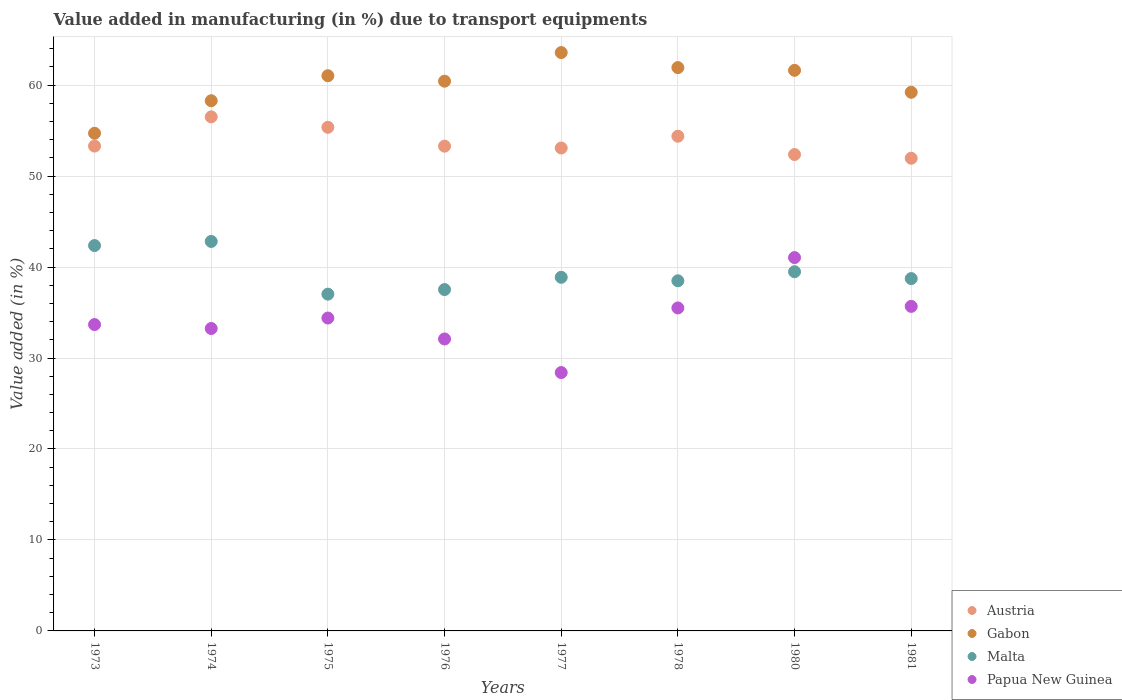How many different coloured dotlines are there?
Provide a short and direct response. 4. Is the number of dotlines equal to the number of legend labels?
Provide a short and direct response. Yes. What is the percentage of value added in manufacturing due to transport equipments in Austria in 1977?
Provide a succinct answer. 53.09. Across all years, what is the maximum percentage of value added in manufacturing due to transport equipments in Gabon?
Ensure brevity in your answer.  63.58. Across all years, what is the minimum percentage of value added in manufacturing due to transport equipments in Papua New Guinea?
Give a very brief answer. 28.4. In which year was the percentage of value added in manufacturing due to transport equipments in Papua New Guinea minimum?
Provide a succinct answer. 1977. What is the total percentage of value added in manufacturing due to transport equipments in Papua New Guinea in the graph?
Offer a terse response. 274.05. What is the difference between the percentage of value added in manufacturing due to transport equipments in Austria in 1973 and that in 1980?
Offer a very short reply. 0.93. What is the difference between the percentage of value added in manufacturing due to transport equipments in Malta in 1980 and the percentage of value added in manufacturing due to transport equipments in Papua New Guinea in 1976?
Provide a short and direct response. 7.39. What is the average percentage of value added in manufacturing due to transport equipments in Malta per year?
Keep it short and to the point. 39.41. In the year 1978, what is the difference between the percentage of value added in manufacturing due to transport equipments in Malta and percentage of value added in manufacturing due to transport equipments in Gabon?
Your answer should be compact. -23.44. In how many years, is the percentage of value added in manufacturing due to transport equipments in Gabon greater than 54 %?
Ensure brevity in your answer.  8. What is the ratio of the percentage of value added in manufacturing due to transport equipments in Austria in 1976 to that in 1978?
Offer a terse response. 0.98. Is the difference between the percentage of value added in manufacturing due to transport equipments in Malta in 1980 and 1981 greater than the difference between the percentage of value added in manufacturing due to transport equipments in Gabon in 1980 and 1981?
Your response must be concise. No. What is the difference between the highest and the second highest percentage of value added in manufacturing due to transport equipments in Papua New Guinea?
Ensure brevity in your answer.  5.36. What is the difference between the highest and the lowest percentage of value added in manufacturing due to transport equipments in Malta?
Give a very brief answer. 5.8. Is the sum of the percentage of value added in manufacturing due to transport equipments in Gabon in 1973 and 1976 greater than the maximum percentage of value added in manufacturing due to transport equipments in Malta across all years?
Provide a short and direct response. Yes. Is it the case that in every year, the sum of the percentage of value added in manufacturing due to transport equipments in Malta and percentage of value added in manufacturing due to transport equipments in Austria  is greater than the sum of percentage of value added in manufacturing due to transport equipments in Gabon and percentage of value added in manufacturing due to transport equipments in Papua New Guinea?
Offer a terse response. No. Is the percentage of value added in manufacturing due to transport equipments in Gabon strictly greater than the percentage of value added in manufacturing due to transport equipments in Papua New Guinea over the years?
Offer a very short reply. Yes. Is the percentage of value added in manufacturing due to transport equipments in Austria strictly less than the percentage of value added in manufacturing due to transport equipments in Gabon over the years?
Your response must be concise. Yes. How many years are there in the graph?
Offer a terse response. 8. Does the graph contain any zero values?
Your response must be concise. No. Does the graph contain grids?
Keep it short and to the point. Yes. Where does the legend appear in the graph?
Offer a very short reply. Bottom right. How many legend labels are there?
Make the answer very short. 4. How are the legend labels stacked?
Ensure brevity in your answer.  Vertical. What is the title of the graph?
Offer a very short reply. Value added in manufacturing (in %) due to transport equipments. What is the label or title of the X-axis?
Your response must be concise. Years. What is the label or title of the Y-axis?
Provide a short and direct response. Value added (in %). What is the Value added (in %) in Austria in 1973?
Provide a succinct answer. 53.3. What is the Value added (in %) in Gabon in 1973?
Give a very brief answer. 54.71. What is the Value added (in %) in Malta in 1973?
Ensure brevity in your answer.  42.36. What is the Value added (in %) in Papua New Guinea in 1973?
Give a very brief answer. 33.68. What is the Value added (in %) in Austria in 1974?
Your response must be concise. 56.51. What is the Value added (in %) of Gabon in 1974?
Provide a short and direct response. 58.29. What is the Value added (in %) in Malta in 1974?
Provide a succinct answer. 42.82. What is the Value added (in %) in Papua New Guinea in 1974?
Your response must be concise. 33.25. What is the Value added (in %) of Austria in 1975?
Give a very brief answer. 55.36. What is the Value added (in %) of Gabon in 1975?
Keep it short and to the point. 61.03. What is the Value added (in %) in Malta in 1975?
Ensure brevity in your answer.  37.02. What is the Value added (in %) in Papua New Guinea in 1975?
Ensure brevity in your answer.  34.4. What is the Value added (in %) in Austria in 1976?
Keep it short and to the point. 53.29. What is the Value added (in %) in Gabon in 1976?
Your answer should be very brief. 60.43. What is the Value added (in %) in Malta in 1976?
Your response must be concise. 37.53. What is the Value added (in %) in Papua New Guinea in 1976?
Give a very brief answer. 32.1. What is the Value added (in %) of Austria in 1977?
Provide a succinct answer. 53.09. What is the Value added (in %) of Gabon in 1977?
Your answer should be very brief. 63.58. What is the Value added (in %) in Malta in 1977?
Give a very brief answer. 38.88. What is the Value added (in %) of Papua New Guinea in 1977?
Offer a very short reply. 28.4. What is the Value added (in %) of Austria in 1978?
Keep it short and to the point. 54.38. What is the Value added (in %) in Gabon in 1978?
Make the answer very short. 61.93. What is the Value added (in %) in Malta in 1978?
Provide a short and direct response. 38.49. What is the Value added (in %) in Papua New Guinea in 1978?
Ensure brevity in your answer.  35.51. What is the Value added (in %) in Austria in 1980?
Provide a short and direct response. 52.37. What is the Value added (in %) in Gabon in 1980?
Ensure brevity in your answer.  61.63. What is the Value added (in %) of Malta in 1980?
Ensure brevity in your answer.  39.49. What is the Value added (in %) of Papua New Guinea in 1980?
Your answer should be compact. 41.04. What is the Value added (in %) in Austria in 1981?
Your answer should be compact. 51.96. What is the Value added (in %) of Gabon in 1981?
Give a very brief answer. 59.22. What is the Value added (in %) in Malta in 1981?
Ensure brevity in your answer.  38.73. What is the Value added (in %) in Papua New Guinea in 1981?
Keep it short and to the point. 35.68. Across all years, what is the maximum Value added (in %) of Austria?
Offer a very short reply. 56.51. Across all years, what is the maximum Value added (in %) of Gabon?
Give a very brief answer. 63.58. Across all years, what is the maximum Value added (in %) of Malta?
Your answer should be very brief. 42.82. Across all years, what is the maximum Value added (in %) in Papua New Guinea?
Your answer should be very brief. 41.04. Across all years, what is the minimum Value added (in %) of Austria?
Your response must be concise. 51.96. Across all years, what is the minimum Value added (in %) of Gabon?
Your answer should be very brief. 54.71. Across all years, what is the minimum Value added (in %) in Malta?
Keep it short and to the point. 37.02. Across all years, what is the minimum Value added (in %) of Papua New Guinea?
Offer a terse response. 28.4. What is the total Value added (in %) in Austria in the graph?
Give a very brief answer. 430.28. What is the total Value added (in %) of Gabon in the graph?
Give a very brief answer. 480.81. What is the total Value added (in %) of Malta in the graph?
Offer a very short reply. 315.32. What is the total Value added (in %) in Papua New Guinea in the graph?
Your response must be concise. 274.05. What is the difference between the Value added (in %) in Austria in 1973 and that in 1974?
Keep it short and to the point. -3.21. What is the difference between the Value added (in %) in Gabon in 1973 and that in 1974?
Your answer should be very brief. -3.58. What is the difference between the Value added (in %) of Malta in 1973 and that in 1974?
Keep it short and to the point. -0.45. What is the difference between the Value added (in %) in Papua New Guinea in 1973 and that in 1974?
Make the answer very short. 0.43. What is the difference between the Value added (in %) in Austria in 1973 and that in 1975?
Your answer should be compact. -2.06. What is the difference between the Value added (in %) of Gabon in 1973 and that in 1975?
Keep it short and to the point. -6.32. What is the difference between the Value added (in %) in Malta in 1973 and that in 1975?
Provide a succinct answer. 5.34. What is the difference between the Value added (in %) in Papua New Guinea in 1973 and that in 1975?
Offer a terse response. -0.72. What is the difference between the Value added (in %) in Austria in 1973 and that in 1976?
Make the answer very short. 0.01. What is the difference between the Value added (in %) of Gabon in 1973 and that in 1976?
Your response must be concise. -5.72. What is the difference between the Value added (in %) in Malta in 1973 and that in 1976?
Your answer should be compact. 4.84. What is the difference between the Value added (in %) of Papua New Guinea in 1973 and that in 1976?
Offer a terse response. 1.58. What is the difference between the Value added (in %) of Austria in 1973 and that in 1977?
Offer a terse response. 0.21. What is the difference between the Value added (in %) in Gabon in 1973 and that in 1977?
Your answer should be compact. -8.87. What is the difference between the Value added (in %) in Malta in 1973 and that in 1977?
Provide a succinct answer. 3.49. What is the difference between the Value added (in %) in Papua New Guinea in 1973 and that in 1977?
Provide a succinct answer. 5.28. What is the difference between the Value added (in %) of Austria in 1973 and that in 1978?
Provide a short and direct response. -1.08. What is the difference between the Value added (in %) of Gabon in 1973 and that in 1978?
Keep it short and to the point. -7.22. What is the difference between the Value added (in %) of Malta in 1973 and that in 1978?
Provide a succinct answer. 3.87. What is the difference between the Value added (in %) in Papua New Guinea in 1973 and that in 1978?
Give a very brief answer. -1.83. What is the difference between the Value added (in %) of Austria in 1973 and that in 1980?
Your answer should be compact. 0.93. What is the difference between the Value added (in %) in Gabon in 1973 and that in 1980?
Provide a succinct answer. -6.92. What is the difference between the Value added (in %) in Malta in 1973 and that in 1980?
Ensure brevity in your answer.  2.88. What is the difference between the Value added (in %) in Papua New Guinea in 1973 and that in 1980?
Provide a succinct answer. -7.36. What is the difference between the Value added (in %) in Austria in 1973 and that in 1981?
Your response must be concise. 1.34. What is the difference between the Value added (in %) of Gabon in 1973 and that in 1981?
Your response must be concise. -4.51. What is the difference between the Value added (in %) in Malta in 1973 and that in 1981?
Provide a short and direct response. 3.63. What is the difference between the Value added (in %) in Papua New Guinea in 1973 and that in 1981?
Your answer should be compact. -2. What is the difference between the Value added (in %) in Austria in 1974 and that in 1975?
Provide a short and direct response. 1.15. What is the difference between the Value added (in %) of Gabon in 1974 and that in 1975?
Ensure brevity in your answer.  -2.75. What is the difference between the Value added (in %) in Malta in 1974 and that in 1975?
Ensure brevity in your answer.  5.8. What is the difference between the Value added (in %) of Papua New Guinea in 1974 and that in 1975?
Your answer should be compact. -1.15. What is the difference between the Value added (in %) of Austria in 1974 and that in 1976?
Keep it short and to the point. 3.22. What is the difference between the Value added (in %) of Gabon in 1974 and that in 1976?
Provide a short and direct response. -2.15. What is the difference between the Value added (in %) in Malta in 1974 and that in 1976?
Provide a succinct answer. 5.29. What is the difference between the Value added (in %) of Papua New Guinea in 1974 and that in 1976?
Provide a succinct answer. 1.15. What is the difference between the Value added (in %) of Austria in 1974 and that in 1977?
Your response must be concise. 3.42. What is the difference between the Value added (in %) in Gabon in 1974 and that in 1977?
Offer a terse response. -5.29. What is the difference between the Value added (in %) of Malta in 1974 and that in 1977?
Your answer should be very brief. 3.94. What is the difference between the Value added (in %) of Papua New Guinea in 1974 and that in 1977?
Ensure brevity in your answer.  4.84. What is the difference between the Value added (in %) in Austria in 1974 and that in 1978?
Provide a short and direct response. 2.13. What is the difference between the Value added (in %) of Gabon in 1974 and that in 1978?
Your response must be concise. -3.64. What is the difference between the Value added (in %) in Malta in 1974 and that in 1978?
Provide a short and direct response. 4.32. What is the difference between the Value added (in %) of Papua New Guinea in 1974 and that in 1978?
Provide a short and direct response. -2.26. What is the difference between the Value added (in %) in Austria in 1974 and that in 1980?
Your response must be concise. 4.14. What is the difference between the Value added (in %) in Gabon in 1974 and that in 1980?
Make the answer very short. -3.34. What is the difference between the Value added (in %) of Malta in 1974 and that in 1980?
Your answer should be very brief. 3.33. What is the difference between the Value added (in %) of Papua New Guinea in 1974 and that in 1980?
Offer a very short reply. -7.8. What is the difference between the Value added (in %) of Austria in 1974 and that in 1981?
Ensure brevity in your answer.  4.55. What is the difference between the Value added (in %) in Gabon in 1974 and that in 1981?
Give a very brief answer. -0.93. What is the difference between the Value added (in %) in Malta in 1974 and that in 1981?
Offer a terse response. 4.08. What is the difference between the Value added (in %) of Papua New Guinea in 1974 and that in 1981?
Offer a terse response. -2.43. What is the difference between the Value added (in %) of Austria in 1975 and that in 1976?
Your answer should be compact. 2.07. What is the difference between the Value added (in %) in Gabon in 1975 and that in 1976?
Offer a terse response. 0.6. What is the difference between the Value added (in %) in Malta in 1975 and that in 1976?
Your response must be concise. -0.5. What is the difference between the Value added (in %) of Papua New Guinea in 1975 and that in 1976?
Provide a short and direct response. 2.3. What is the difference between the Value added (in %) of Austria in 1975 and that in 1977?
Your answer should be very brief. 2.27. What is the difference between the Value added (in %) of Gabon in 1975 and that in 1977?
Offer a terse response. -2.55. What is the difference between the Value added (in %) in Malta in 1975 and that in 1977?
Offer a terse response. -1.85. What is the difference between the Value added (in %) of Papua New Guinea in 1975 and that in 1977?
Offer a terse response. 5.99. What is the difference between the Value added (in %) in Austria in 1975 and that in 1978?
Your answer should be compact. 0.98. What is the difference between the Value added (in %) of Gabon in 1975 and that in 1978?
Offer a terse response. -0.89. What is the difference between the Value added (in %) in Malta in 1975 and that in 1978?
Your answer should be compact. -1.47. What is the difference between the Value added (in %) in Papua New Guinea in 1975 and that in 1978?
Make the answer very short. -1.11. What is the difference between the Value added (in %) in Austria in 1975 and that in 1980?
Offer a terse response. 2.99. What is the difference between the Value added (in %) in Gabon in 1975 and that in 1980?
Give a very brief answer. -0.59. What is the difference between the Value added (in %) in Malta in 1975 and that in 1980?
Offer a very short reply. -2.47. What is the difference between the Value added (in %) of Papua New Guinea in 1975 and that in 1980?
Your answer should be compact. -6.65. What is the difference between the Value added (in %) of Austria in 1975 and that in 1981?
Offer a very short reply. 3.4. What is the difference between the Value added (in %) in Gabon in 1975 and that in 1981?
Make the answer very short. 1.82. What is the difference between the Value added (in %) of Malta in 1975 and that in 1981?
Keep it short and to the point. -1.71. What is the difference between the Value added (in %) of Papua New Guinea in 1975 and that in 1981?
Your answer should be very brief. -1.28. What is the difference between the Value added (in %) of Austria in 1976 and that in 1977?
Give a very brief answer. 0.2. What is the difference between the Value added (in %) in Gabon in 1976 and that in 1977?
Give a very brief answer. -3.15. What is the difference between the Value added (in %) of Malta in 1976 and that in 1977?
Offer a very short reply. -1.35. What is the difference between the Value added (in %) in Papua New Guinea in 1976 and that in 1977?
Keep it short and to the point. 3.69. What is the difference between the Value added (in %) in Austria in 1976 and that in 1978?
Provide a succinct answer. -1.09. What is the difference between the Value added (in %) in Gabon in 1976 and that in 1978?
Your answer should be compact. -1.49. What is the difference between the Value added (in %) of Malta in 1976 and that in 1978?
Offer a terse response. -0.97. What is the difference between the Value added (in %) of Papua New Guinea in 1976 and that in 1978?
Make the answer very short. -3.41. What is the difference between the Value added (in %) of Austria in 1976 and that in 1980?
Offer a terse response. 0.92. What is the difference between the Value added (in %) of Gabon in 1976 and that in 1980?
Keep it short and to the point. -1.19. What is the difference between the Value added (in %) of Malta in 1976 and that in 1980?
Offer a terse response. -1.96. What is the difference between the Value added (in %) of Papua New Guinea in 1976 and that in 1980?
Provide a succinct answer. -8.95. What is the difference between the Value added (in %) in Austria in 1976 and that in 1981?
Keep it short and to the point. 1.33. What is the difference between the Value added (in %) in Gabon in 1976 and that in 1981?
Offer a very short reply. 1.22. What is the difference between the Value added (in %) of Malta in 1976 and that in 1981?
Provide a succinct answer. -1.21. What is the difference between the Value added (in %) in Papua New Guinea in 1976 and that in 1981?
Your response must be concise. -3.58. What is the difference between the Value added (in %) of Austria in 1977 and that in 1978?
Offer a very short reply. -1.29. What is the difference between the Value added (in %) in Gabon in 1977 and that in 1978?
Give a very brief answer. 1.65. What is the difference between the Value added (in %) of Malta in 1977 and that in 1978?
Your response must be concise. 0.38. What is the difference between the Value added (in %) in Papua New Guinea in 1977 and that in 1978?
Your answer should be very brief. -7.1. What is the difference between the Value added (in %) of Austria in 1977 and that in 1980?
Your answer should be compact. 0.72. What is the difference between the Value added (in %) of Gabon in 1977 and that in 1980?
Make the answer very short. 1.95. What is the difference between the Value added (in %) in Malta in 1977 and that in 1980?
Ensure brevity in your answer.  -0.61. What is the difference between the Value added (in %) of Papua New Guinea in 1977 and that in 1980?
Provide a succinct answer. -12.64. What is the difference between the Value added (in %) in Austria in 1977 and that in 1981?
Give a very brief answer. 1.13. What is the difference between the Value added (in %) in Gabon in 1977 and that in 1981?
Your answer should be very brief. 4.36. What is the difference between the Value added (in %) in Malta in 1977 and that in 1981?
Your response must be concise. 0.14. What is the difference between the Value added (in %) in Papua New Guinea in 1977 and that in 1981?
Your response must be concise. -7.28. What is the difference between the Value added (in %) in Austria in 1978 and that in 1980?
Offer a very short reply. 2.01. What is the difference between the Value added (in %) of Gabon in 1978 and that in 1980?
Your answer should be compact. 0.3. What is the difference between the Value added (in %) in Malta in 1978 and that in 1980?
Offer a terse response. -0.99. What is the difference between the Value added (in %) of Papua New Guinea in 1978 and that in 1980?
Offer a terse response. -5.54. What is the difference between the Value added (in %) of Austria in 1978 and that in 1981?
Offer a terse response. 2.42. What is the difference between the Value added (in %) in Gabon in 1978 and that in 1981?
Provide a short and direct response. 2.71. What is the difference between the Value added (in %) in Malta in 1978 and that in 1981?
Ensure brevity in your answer.  -0.24. What is the difference between the Value added (in %) in Papua New Guinea in 1978 and that in 1981?
Your answer should be compact. -0.17. What is the difference between the Value added (in %) in Austria in 1980 and that in 1981?
Your answer should be compact. 0.41. What is the difference between the Value added (in %) of Gabon in 1980 and that in 1981?
Provide a succinct answer. 2.41. What is the difference between the Value added (in %) of Malta in 1980 and that in 1981?
Provide a succinct answer. 0.75. What is the difference between the Value added (in %) of Papua New Guinea in 1980 and that in 1981?
Provide a short and direct response. 5.36. What is the difference between the Value added (in %) in Austria in 1973 and the Value added (in %) in Gabon in 1974?
Ensure brevity in your answer.  -4.98. What is the difference between the Value added (in %) of Austria in 1973 and the Value added (in %) of Malta in 1974?
Your answer should be very brief. 10.48. What is the difference between the Value added (in %) in Austria in 1973 and the Value added (in %) in Papua New Guinea in 1974?
Your answer should be very brief. 20.06. What is the difference between the Value added (in %) in Gabon in 1973 and the Value added (in %) in Malta in 1974?
Your answer should be very brief. 11.89. What is the difference between the Value added (in %) of Gabon in 1973 and the Value added (in %) of Papua New Guinea in 1974?
Your answer should be very brief. 21.46. What is the difference between the Value added (in %) of Malta in 1973 and the Value added (in %) of Papua New Guinea in 1974?
Your response must be concise. 9.12. What is the difference between the Value added (in %) of Austria in 1973 and the Value added (in %) of Gabon in 1975?
Your answer should be compact. -7.73. What is the difference between the Value added (in %) in Austria in 1973 and the Value added (in %) in Malta in 1975?
Your response must be concise. 16.28. What is the difference between the Value added (in %) of Austria in 1973 and the Value added (in %) of Papua New Guinea in 1975?
Your answer should be very brief. 18.91. What is the difference between the Value added (in %) of Gabon in 1973 and the Value added (in %) of Malta in 1975?
Offer a very short reply. 17.69. What is the difference between the Value added (in %) in Gabon in 1973 and the Value added (in %) in Papua New Guinea in 1975?
Ensure brevity in your answer.  20.31. What is the difference between the Value added (in %) in Malta in 1973 and the Value added (in %) in Papua New Guinea in 1975?
Your answer should be very brief. 7.97. What is the difference between the Value added (in %) in Austria in 1973 and the Value added (in %) in Gabon in 1976?
Provide a succinct answer. -7.13. What is the difference between the Value added (in %) in Austria in 1973 and the Value added (in %) in Malta in 1976?
Ensure brevity in your answer.  15.78. What is the difference between the Value added (in %) of Austria in 1973 and the Value added (in %) of Papua New Guinea in 1976?
Provide a short and direct response. 21.21. What is the difference between the Value added (in %) of Gabon in 1973 and the Value added (in %) of Malta in 1976?
Offer a very short reply. 17.18. What is the difference between the Value added (in %) in Gabon in 1973 and the Value added (in %) in Papua New Guinea in 1976?
Your answer should be compact. 22.61. What is the difference between the Value added (in %) of Malta in 1973 and the Value added (in %) of Papua New Guinea in 1976?
Provide a short and direct response. 10.27. What is the difference between the Value added (in %) of Austria in 1973 and the Value added (in %) of Gabon in 1977?
Provide a short and direct response. -10.28. What is the difference between the Value added (in %) of Austria in 1973 and the Value added (in %) of Malta in 1977?
Provide a short and direct response. 14.43. What is the difference between the Value added (in %) of Austria in 1973 and the Value added (in %) of Papua New Guinea in 1977?
Offer a terse response. 24.9. What is the difference between the Value added (in %) in Gabon in 1973 and the Value added (in %) in Malta in 1977?
Give a very brief answer. 15.83. What is the difference between the Value added (in %) of Gabon in 1973 and the Value added (in %) of Papua New Guinea in 1977?
Offer a terse response. 26.31. What is the difference between the Value added (in %) of Malta in 1973 and the Value added (in %) of Papua New Guinea in 1977?
Your answer should be very brief. 13.96. What is the difference between the Value added (in %) of Austria in 1973 and the Value added (in %) of Gabon in 1978?
Ensure brevity in your answer.  -8.63. What is the difference between the Value added (in %) in Austria in 1973 and the Value added (in %) in Malta in 1978?
Your answer should be compact. 14.81. What is the difference between the Value added (in %) in Austria in 1973 and the Value added (in %) in Papua New Guinea in 1978?
Provide a short and direct response. 17.79. What is the difference between the Value added (in %) in Gabon in 1973 and the Value added (in %) in Malta in 1978?
Provide a short and direct response. 16.22. What is the difference between the Value added (in %) of Gabon in 1973 and the Value added (in %) of Papua New Guinea in 1978?
Your answer should be very brief. 19.2. What is the difference between the Value added (in %) of Malta in 1973 and the Value added (in %) of Papua New Guinea in 1978?
Keep it short and to the point. 6.86. What is the difference between the Value added (in %) of Austria in 1973 and the Value added (in %) of Gabon in 1980?
Offer a very short reply. -8.32. What is the difference between the Value added (in %) of Austria in 1973 and the Value added (in %) of Malta in 1980?
Your response must be concise. 13.81. What is the difference between the Value added (in %) of Austria in 1973 and the Value added (in %) of Papua New Guinea in 1980?
Offer a terse response. 12.26. What is the difference between the Value added (in %) in Gabon in 1973 and the Value added (in %) in Malta in 1980?
Ensure brevity in your answer.  15.22. What is the difference between the Value added (in %) of Gabon in 1973 and the Value added (in %) of Papua New Guinea in 1980?
Provide a short and direct response. 13.67. What is the difference between the Value added (in %) in Malta in 1973 and the Value added (in %) in Papua New Guinea in 1980?
Your answer should be very brief. 1.32. What is the difference between the Value added (in %) of Austria in 1973 and the Value added (in %) of Gabon in 1981?
Ensure brevity in your answer.  -5.91. What is the difference between the Value added (in %) of Austria in 1973 and the Value added (in %) of Malta in 1981?
Provide a succinct answer. 14.57. What is the difference between the Value added (in %) of Austria in 1973 and the Value added (in %) of Papua New Guinea in 1981?
Provide a short and direct response. 17.62. What is the difference between the Value added (in %) in Gabon in 1973 and the Value added (in %) in Malta in 1981?
Give a very brief answer. 15.98. What is the difference between the Value added (in %) in Gabon in 1973 and the Value added (in %) in Papua New Guinea in 1981?
Your answer should be very brief. 19.03. What is the difference between the Value added (in %) of Malta in 1973 and the Value added (in %) of Papua New Guinea in 1981?
Give a very brief answer. 6.68. What is the difference between the Value added (in %) in Austria in 1974 and the Value added (in %) in Gabon in 1975?
Offer a very short reply. -4.52. What is the difference between the Value added (in %) in Austria in 1974 and the Value added (in %) in Malta in 1975?
Provide a short and direct response. 19.49. What is the difference between the Value added (in %) of Austria in 1974 and the Value added (in %) of Papua New Guinea in 1975?
Offer a terse response. 22.12. What is the difference between the Value added (in %) of Gabon in 1974 and the Value added (in %) of Malta in 1975?
Offer a terse response. 21.26. What is the difference between the Value added (in %) of Gabon in 1974 and the Value added (in %) of Papua New Guinea in 1975?
Your response must be concise. 23.89. What is the difference between the Value added (in %) of Malta in 1974 and the Value added (in %) of Papua New Guinea in 1975?
Your answer should be compact. 8.42. What is the difference between the Value added (in %) of Austria in 1974 and the Value added (in %) of Gabon in 1976?
Your response must be concise. -3.92. What is the difference between the Value added (in %) of Austria in 1974 and the Value added (in %) of Malta in 1976?
Offer a very short reply. 18.99. What is the difference between the Value added (in %) of Austria in 1974 and the Value added (in %) of Papua New Guinea in 1976?
Provide a short and direct response. 24.42. What is the difference between the Value added (in %) in Gabon in 1974 and the Value added (in %) in Malta in 1976?
Ensure brevity in your answer.  20.76. What is the difference between the Value added (in %) of Gabon in 1974 and the Value added (in %) of Papua New Guinea in 1976?
Provide a succinct answer. 26.19. What is the difference between the Value added (in %) of Malta in 1974 and the Value added (in %) of Papua New Guinea in 1976?
Your response must be concise. 10.72. What is the difference between the Value added (in %) in Austria in 1974 and the Value added (in %) in Gabon in 1977?
Your answer should be compact. -7.07. What is the difference between the Value added (in %) in Austria in 1974 and the Value added (in %) in Malta in 1977?
Your answer should be very brief. 17.64. What is the difference between the Value added (in %) of Austria in 1974 and the Value added (in %) of Papua New Guinea in 1977?
Provide a succinct answer. 28.11. What is the difference between the Value added (in %) of Gabon in 1974 and the Value added (in %) of Malta in 1977?
Provide a short and direct response. 19.41. What is the difference between the Value added (in %) in Gabon in 1974 and the Value added (in %) in Papua New Guinea in 1977?
Keep it short and to the point. 29.88. What is the difference between the Value added (in %) in Malta in 1974 and the Value added (in %) in Papua New Guinea in 1977?
Offer a very short reply. 14.41. What is the difference between the Value added (in %) in Austria in 1974 and the Value added (in %) in Gabon in 1978?
Your response must be concise. -5.41. What is the difference between the Value added (in %) in Austria in 1974 and the Value added (in %) in Malta in 1978?
Your response must be concise. 18.02. What is the difference between the Value added (in %) of Austria in 1974 and the Value added (in %) of Papua New Guinea in 1978?
Provide a short and direct response. 21.01. What is the difference between the Value added (in %) in Gabon in 1974 and the Value added (in %) in Malta in 1978?
Offer a terse response. 19.79. What is the difference between the Value added (in %) in Gabon in 1974 and the Value added (in %) in Papua New Guinea in 1978?
Make the answer very short. 22.78. What is the difference between the Value added (in %) of Malta in 1974 and the Value added (in %) of Papua New Guinea in 1978?
Your response must be concise. 7.31. What is the difference between the Value added (in %) in Austria in 1974 and the Value added (in %) in Gabon in 1980?
Provide a short and direct response. -5.11. What is the difference between the Value added (in %) in Austria in 1974 and the Value added (in %) in Malta in 1980?
Give a very brief answer. 17.03. What is the difference between the Value added (in %) of Austria in 1974 and the Value added (in %) of Papua New Guinea in 1980?
Your response must be concise. 15.47. What is the difference between the Value added (in %) in Gabon in 1974 and the Value added (in %) in Malta in 1980?
Give a very brief answer. 18.8. What is the difference between the Value added (in %) in Gabon in 1974 and the Value added (in %) in Papua New Guinea in 1980?
Provide a succinct answer. 17.24. What is the difference between the Value added (in %) in Malta in 1974 and the Value added (in %) in Papua New Guinea in 1980?
Make the answer very short. 1.77. What is the difference between the Value added (in %) in Austria in 1974 and the Value added (in %) in Gabon in 1981?
Your answer should be very brief. -2.7. What is the difference between the Value added (in %) in Austria in 1974 and the Value added (in %) in Malta in 1981?
Make the answer very short. 17.78. What is the difference between the Value added (in %) in Austria in 1974 and the Value added (in %) in Papua New Guinea in 1981?
Keep it short and to the point. 20.83. What is the difference between the Value added (in %) of Gabon in 1974 and the Value added (in %) of Malta in 1981?
Offer a very short reply. 19.55. What is the difference between the Value added (in %) in Gabon in 1974 and the Value added (in %) in Papua New Guinea in 1981?
Give a very brief answer. 22.61. What is the difference between the Value added (in %) of Malta in 1974 and the Value added (in %) of Papua New Guinea in 1981?
Your answer should be very brief. 7.14. What is the difference between the Value added (in %) in Austria in 1975 and the Value added (in %) in Gabon in 1976?
Your response must be concise. -5.07. What is the difference between the Value added (in %) of Austria in 1975 and the Value added (in %) of Malta in 1976?
Provide a short and direct response. 17.84. What is the difference between the Value added (in %) of Austria in 1975 and the Value added (in %) of Papua New Guinea in 1976?
Provide a succinct answer. 23.27. What is the difference between the Value added (in %) in Gabon in 1975 and the Value added (in %) in Malta in 1976?
Provide a short and direct response. 23.51. What is the difference between the Value added (in %) in Gabon in 1975 and the Value added (in %) in Papua New Guinea in 1976?
Offer a terse response. 28.94. What is the difference between the Value added (in %) in Malta in 1975 and the Value added (in %) in Papua New Guinea in 1976?
Your answer should be compact. 4.93. What is the difference between the Value added (in %) of Austria in 1975 and the Value added (in %) of Gabon in 1977?
Make the answer very short. -8.22. What is the difference between the Value added (in %) of Austria in 1975 and the Value added (in %) of Malta in 1977?
Make the answer very short. 16.49. What is the difference between the Value added (in %) of Austria in 1975 and the Value added (in %) of Papua New Guinea in 1977?
Offer a terse response. 26.96. What is the difference between the Value added (in %) of Gabon in 1975 and the Value added (in %) of Malta in 1977?
Give a very brief answer. 22.16. What is the difference between the Value added (in %) of Gabon in 1975 and the Value added (in %) of Papua New Guinea in 1977?
Provide a short and direct response. 32.63. What is the difference between the Value added (in %) in Malta in 1975 and the Value added (in %) in Papua New Guinea in 1977?
Offer a terse response. 8.62. What is the difference between the Value added (in %) in Austria in 1975 and the Value added (in %) in Gabon in 1978?
Give a very brief answer. -6.56. What is the difference between the Value added (in %) in Austria in 1975 and the Value added (in %) in Malta in 1978?
Your response must be concise. 16.87. What is the difference between the Value added (in %) in Austria in 1975 and the Value added (in %) in Papua New Guinea in 1978?
Your answer should be compact. 19.86. What is the difference between the Value added (in %) of Gabon in 1975 and the Value added (in %) of Malta in 1978?
Ensure brevity in your answer.  22.54. What is the difference between the Value added (in %) in Gabon in 1975 and the Value added (in %) in Papua New Guinea in 1978?
Your response must be concise. 25.53. What is the difference between the Value added (in %) of Malta in 1975 and the Value added (in %) of Papua New Guinea in 1978?
Offer a terse response. 1.51. What is the difference between the Value added (in %) of Austria in 1975 and the Value added (in %) of Gabon in 1980?
Provide a short and direct response. -6.26. What is the difference between the Value added (in %) in Austria in 1975 and the Value added (in %) in Malta in 1980?
Offer a terse response. 15.88. What is the difference between the Value added (in %) in Austria in 1975 and the Value added (in %) in Papua New Guinea in 1980?
Make the answer very short. 14.32. What is the difference between the Value added (in %) in Gabon in 1975 and the Value added (in %) in Malta in 1980?
Your response must be concise. 21.55. What is the difference between the Value added (in %) of Gabon in 1975 and the Value added (in %) of Papua New Guinea in 1980?
Make the answer very short. 19.99. What is the difference between the Value added (in %) in Malta in 1975 and the Value added (in %) in Papua New Guinea in 1980?
Ensure brevity in your answer.  -4.02. What is the difference between the Value added (in %) of Austria in 1975 and the Value added (in %) of Gabon in 1981?
Your answer should be compact. -3.85. What is the difference between the Value added (in %) of Austria in 1975 and the Value added (in %) of Malta in 1981?
Your answer should be very brief. 16.63. What is the difference between the Value added (in %) of Austria in 1975 and the Value added (in %) of Papua New Guinea in 1981?
Your response must be concise. 19.68. What is the difference between the Value added (in %) of Gabon in 1975 and the Value added (in %) of Malta in 1981?
Provide a short and direct response. 22.3. What is the difference between the Value added (in %) of Gabon in 1975 and the Value added (in %) of Papua New Guinea in 1981?
Your answer should be very brief. 25.35. What is the difference between the Value added (in %) in Malta in 1975 and the Value added (in %) in Papua New Guinea in 1981?
Your answer should be very brief. 1.34. What is the difference between the Value added (in %) of Austria in 1976 and the Value added (in %) of Gabon in 1977?
Your response must be concise. -10.29. What is the difference between the Value added (in %) of Austria in 1976 and the Value added (in %) of Malta in 1977?
Keep it short and to the point. 14.42. What is the difference between the Value added (in %) in Austria in 1976 and the Value added (in %) in Papua New Guinea in 1977?
Your answer should be very brief. 24.89. What is the difference between the Value added (in %) of Gabon in 1976 and the Value added (in %) of Malta in 1977?
Offer a very short reply. 21.56. What is the difference between the Value added (in %) in Gabon in 1976 and the Value added (in %) in Papua New Guinea in 1977?
Give a very brief answer. 32.03. What is the difference between the Value added (in %) of Malta in 1976 and the Value added (in %) of Papua New Guinea in 1977?
Ensure brevity in your answer.  9.12. What is the difference between the Value added (in %) in Austria in 1976 and the Value added (in %) in Gabon in 1978?
Keep it short and to the point. -8.64. What is the difference between the Value added (in %) of Austria in 1976 and the Value added (in %) of Malta in 1978?
Your answer should be compact. 14.8. What is the difference between the Value added (in %) of Austria in 1976 and the Value added (in %) of Papua New Guinea in 1978?
Your response must be concise. 17.78. What is the difference between the Value added (in %) in Gabon in 1976 and the Value added (in %) in Malta in 1978?
Your response must be concise. 21.94. What is the difference between the Value added (in %) in Gabon in 1976 and the Value added (in %) in Papua New Guinea in 1978?
Your response must be concise. 24.93. What is the difference between the Value added (in %) of Malta in 1976 and the Value added (in %) of Papua New Guinea in 1978?
Provide a short and direct response. 2.02. What is the difference between the Value added (in %) of Austria in 1976 and the Value added (in %) of Gabon in 1980?
Give a very brief answer. -8.34. What is the difference between the Value added (in %) of Austria in 1976 and the Value added (in %) of Malta in 1980?
Ensure brevity in your answer.  13.8. What is the difference between the Value added (in %) in Austria in 1976 and the Value added (in %) in Papua New Guinea in 1980?
Provide a short and direct response. 12.25. What is the difference between the Value added (in %) in Gabon in 1976 and the Value added (in %) in Malta in 1980?
Provide a short and direct response. 20.95. What is the difference between the Value added (in %) in Gabon in 1976 and the Value added (in %) in Papua New Guinea in 1980?
Give a very brief answer. 19.39. What is the difference between the Value added (in %) in Malta in 1976 and the Value added (in %) in Papua New Guinea in 1980?
Provide a succinct answer. -3.52. What is the difference between the Value added (in %) in Austria in 1976 and the Value added (in %) in Gabon in 1981?
Offer a terse response. -5.92. What is the difference between the Value added (in %) of Austria in 1976 and the Value added (in %) of Malta in 1981?
Provide a short and direct response. 14.56. What is the difference between the Value added (in %) of Austria in 1976 and the Value added (in %) of Papua New Guinea in 1981?
Keep it short and to the point. 17.61. What is the difference between the Value added (in %) in Gabon in 1976 and the Value added (in %) in Malta in 1981?
Provide a succinct answer. 21.7. What is the difference between the Value added (in %) in Gabon in 1976 and the Value added (in %) in Papua New Guinea in 1981?
Provide a succinct answer. 24.75. What is the difference between the Value added (in %) in Malta in 1976 and the Value added (in %) in Papua New Guinea in 1981?
Keep it short and to the point. 1.85. What is the difference between the Value added (in %) of Austria in 1977 and the Value added (in %) of Gabon in 1978?
Make the answer very short. -8.84. What is the difference between the Value added (in %) of Austria in 1977 and the Value added (in %) of Malta in 1978?
Offer a very short reply. 14.6. What is the difference between the Value added (in %) of Austria in 1977 and the Value added (in %) of Papua New Guinea in 1978?
Offer a very short reply. 17.58. What is the difference between the Value added (in %) in Gabon in 1977 and the Value added (in %) in Malta in 1978?
Keep it short and to the point. 25.09. What is the difference between the Value added (in %) in Gabon in 1977 and the Value added (in %) in Papua New Guinea in 1978?
Ensure brevity in your answer.  28.07. What is the difference between the Value added (in %) in Malta in 1977 and the Value added (in %) in Papua New Guinea in 1978?
Make the answer very short. 3.37. What is the difference between the Value added (in %) of Austria in 1977 and the Value added (in %) of Gabon in 1980?
Make the answer very short. -8.54. What is the difference between the Value added (in %) of Austria in 1977 and the Value added (in %) of Malta in 1980?
Your answer should be very brief. 13.6. What is the difference between the Value added (in %) of Austria in 1977 and the Value added (in %) of Papua New Guinea in 1980?
Offer a terse response. 12.05. What is the difference between the Value added (in %) of Gabon in 1977 and the Value added (in %) of Malta in 1980?
Offer a terse response. 24.09. What is the difference between the Value added (in %) in Gabon in 1977 and the Value added (in %) in Papua New Guinea in 1980?
Offer a very short reply. 22.54. What is the difference between the Value added (in %) in Malta in 1977 and the Value added (in %) in Papua New Guinea in 1980?
Your answer should be very brief. -2.17. What is the difference between the Value added (in %) of Austria in 1977 and the Value added (in %) of Gabon in 1981?
Provide a succinct answer. -6.13. What is the difference between the Value added (in %) in Austria in 1977 and the Value added (in %) in Malta in 1981?
Ensure brevity in your answer.  14.36. What is the difference between the Value added (in %) in Austria in 1977 and the Value added (in %) in Papua New Guinea in 1981?
Ensure brevity in your answer.  17.41. What is the difference between the Value added (in %) in Gabon in 1977 and the Value added (in %) in Malta in 1981?
Provide a short and direct response. 24.85. What is the difference between the Value added (in %) of Gabon in 1977 and the Value added (in %) of Papua New Guinea in 1981?
Your answer should be very brief. 27.9. What is the difference between the Value added (in %) in Malta in 1977 and the Value added (in %) in Papua New Guinea in 1981?
Your response must be concise. 3.2. What is the difference between the Value added (in %) of Austria in 1978 and the Value added (in %) of Gabon in 1980?
Keep it short and to the point. -7.24. What is the difference between the Value added (in %) of Austria in 1978 and the Value added (in %) of Malta in 1980?
Give a very brief answer. 14.9. What is the difference between the Value added (in %) in Austria in 1978 and the Value added (in %) in Papua New Guinea in 1980?
Your response must be concise. 13.34. What is the difference between the Value added (in %) in Gabon in 1978 and the Value added (in %) in Malta in 1980?
Make the answer very short. 22.44. What is the difference between the Value added (in %) in Gabon in 1978 and the Value added (in %) in Papua New Guinea in 1980?
Give a very brief answer. 20.89. What is the difference between the Value added (in %) of Malta in 1978 and the Value added (in %) of Papua New Guinea in 1980?
Give a very brief answer. -2.55. What is the difference between the Value added (in %) in Austria in 1978 and the Value added (in %) in Gabon in 1981?
Provide a succinct answer. -4.83. What is the difference between the Value added (in %) in Austria in 1978 and the Value added (in %) in Malta in 1981?
Provide a succinct answer. 15.65. What is the difference between the Value added (in %) in Austria in 1978 and the Value added (in %) in Papua New Guinea in 1981?
Give a very brief answer. 18.71. What is the difference between the Value added (in %) in Gabon in 1978 and the Value added (in %) in Malta in 1981?
Make the answer very short. 23.2. What is the difference between the Value added (in %) in Gabon in 1978 and the Value added (in %) in Papua New Guinea in 1981?
Provide a short and direct response. 26.25. What is the difference between the Value added (in %) of Malta in 1978 and the Value added (in %) of Papua New Guinea in 1981?
Your answer should be compact. 2.81. What is the difference between the Value added (in %) in Austria in 1980 and the Value added (in %) in Gabon in 1981?
Provide a succinct answer. -6.84. What is the difference between the Value added (in %) of Austria in 1980 and the Value added (in %) of Malta in 1981?
Ensure brevity in your answer.  13.64. What is the difference between the Value added (in %) in Austria in 1980 and the Value added (in %) in Papua New Guinea in 1981?
Offer a very short reply. 16.69. What is the difference between the Value added (in %) in Gabon in 1980 and the Value added (in %) in Malta in 1981?
Provide a succinct answer. 22.89. What is the difference between the Value added (in %) of Gabon in 1980 and the Value added (in %) of Papua New Guinea in 1981?
Provide a succinct answer. 25.95. What is the difference between the Value added (in %) of Malta in 1980 and the Value added (in %) of Papua New Guinea in 1981?
Ensure brevity in your answer.  3.81. What is the average Value added (in %) in Austria per year?
Provide a succinct answer. 53.78. What is the average Value added (in %) in Gabon per year?
Offer a very short reply. 60.1. What is the average Value added (in %) in Malta per year?
Your answer should be compact. 39.41. What is the average Value added (in %) in Papua New Guinea per year?
Make the answer very short. 34.26. In the year 1973, what is the difference between the Value added (in %) in Austria and Value added (in %) in Gabon?
Make the answer very short. -1.41. In the year 1973, what is the difference between the Value added (in %) of Austria and Value added (in %) of Malta?
Your response must be concise. 10.94. In the year 1973, what is the difference between the Value added (in %) of Austria and Value added (in %) of Papua New Guinea?
Give a very brief answer. 19.62. In the year 1973, what is the difference between the Value added (in %) in Gabon and Value added (in %) in Malta?
Give a very brief answer. 12.35. In the year 1973, what is the difference between the Value added (in %) of Gabon and Value added (in %) of Papua New Guinea?
Give a very brief answer. 21.03. In the year 1973, what is the difference between the Value added (in %) in Malta and Value added (in %) in Papua New Guinea?
Ensure brevity in your answer.  8.68. In the year 1974, what is the difference between the Value added (in %) of Austria and Value added (in %) of Gabon?
Make the answer very short. -1.77. In the year 1974, what is the difference between the Value added (in %) in Austria and Value added (in %) in Malta?
Provide a succinct answer. 13.7. In the year 1974, what is the difference between the Value added (in %) of Austria and Value added (in %) of Papua New Guinea?
Keep it short and to the point. 23.27. In the year 1974, what is the difference between the Value added (in %) of Gabon and Value added (in %) of Malta?
Offer a very short reply. 15.47. In the year 1974, what is the difference between the Value added (in %) of Gabon and Value added (in %) of Papua New Guinea?
Your answer should be very brief. 25.04. In the year 1974, what is the difference between the Value added (in %) of Malta and Value added (in %) of Papua New Guinea?
Make the answer very short. 9.57. In the year 1975, what is the difference between the Value added (in %) of Austria and Value added (in %) of Gabon?
Provide a succinct answer. -5.67. In the year 1975, what is the difference between the Value added (in %) of Austria and Value added (in %) of Malta?
Make the answer very short. 18.34. In the year 1975, what is the difference between the Value added (in %) in Austria and Value added (in %) in Papua New Guinea?
Your answer should be very brief. 20.97. In the year 1975, what is the difference between the Value added (in %) in Gabon and Value added (in %) in Malta?
Your answer should be very brief. 24.01. In the year 1975, what is the difference between the Value added (in %) of Gabon and Value added (in %) of Papua New Guinea?
Provide a succinct answer. 26.64. In the year 1975, what is the difference between the Value added (in %) of Malta and Value added (in %) of Papua New Guinea?
Provide a succinct answer. 2.63. In the year 1976, what is the difference between the Value added (in %) of Austria and Value added (in %) of Gabon?
Make the answer very short. -7.14. In the year 1976, what is the difference between the Value added (in %) of Austria and Value added (in %) of Malta?
Offer a very short reply. 15.77. In the year 1976, what is the difference between the Value added (in %) of Austria and Value added (in %) of Papua New Guinea?
Your response must be concise. 21.2. In the year 1976, what is the difference between the Value added (in %) in Gabon and Value added (in %) in Malta?
Your answer should be compact. 22.91. In the year 1976, what is the difference between the Value added (in %) in Gabon and Value added (in %) in Papua New Guinea?
Offer a very short reply. 28.34. In the year 1976, what is the difference between the Value added (in %) of Malta and Value added (in %) of Papua New Guinea?
Offer a very short reply. 5.43. In the year 1977, what is the difference between the Value added (in %) in Austria and Value added (in %) in Gabon?
Offer a terse response. -10.49. In the year 1977, what is the difference between the Value added (in %) in Austria and Value added (in %) in Malta?
Offer a very short reply. 14.21. In the year 1977, what is the difference between the Value added (in %) in Austria and Value added (in %) in Papua New Guinea?
Keep it short and to the point. 24.69. In the year 1977, what is the difference between the Value added (in %) in Gabon and Value added (in %) in Malta?
Give a very brief answer. 24.7. In the year 1977, what is the difference between the Value added (in %) in Gabon and Value added (in %) in Papua New Guinea?
Give a very brief answer. 35.18. In the year 1977, what is the difference between the Value added (in %) in Malta and Value added (in %) in Papua New Guinea?
Give a very brief answer. 10.47. In the year 1978, what is the difference between the Value added (in %) in Austria and Value added (in %) in Gabon?
Your response must be concise. -7.54. In the year 1978, what is the difference between the Value added (in %) of Austria and Value added (in %) of Malta?
Your answer should be compact. 15.89. In the year 1978, what is the difference between the Value added (in %) in Austria and Value added (in %) in Papua New Guinea?
Ensure brevity in your answer.  18.88. In the year 1978, what is the difference between the Value added (in %) of Gabon and Value added (in %) of Malta?
Your answer should be compact. 23.44. In the year 1978, what is the difference between the Value added (in %) of Gabon and Value added (in %) of Papua New Guinea?
Offer a terse response. 26.42. In the year 1978, what is the difference between the Value added (in %) of Malta and Value added (in %) of Papua New Guinea?
Keep it short and to the point. 2.99. In the year 1980, what is the difference between the Value added (in %) in Austria and Value added (in %) in Gabon?
Keep it short and to the point. -9.25. In the year 1980, what is the difference between the Value added (in %) of Austria and Value added (in %) of Malta?
Your answer should be very brief. 12.88. In the year 1980, what is the difference between the Value added (in %) of Austria and Value added (in %) of Papua New Guinea?
Offer a terse response. 11.33. In the year 1980, what is the difference between the Value added (in %) of Gabon and Value added (in %) of Malta?
Your answer should be compact. 22.14. In the year 1980, what is the difference between the Value added (in %) in Gabon and Value added (in %) in Papua New Guinea?
Make the answer very short. 20.58. In the year 1980, what is the difference between the Value added (in %) of Malta and Value added (in %) of Papua New Guinea?
Make the answer very short. -1.55. In the year 1981, what is the difference between the Value added (in %) of Austria and Value added (in %) of Gabon?
Keep it short and to the point. -7.25. In the year 1981, what is the difference between the Value added (in %) in Austria and Value added (in %) in Malta?
Your answer should be compact. 13.23. In the year 1981, what is the difference between the Value added (in %) of Austria and Value added (in %) of Papua New Guinea?
Offer a very short reply. 16.28. In the year 1981, what is the difference between the Value added (in %) in Gabon and Value added (in %) in Malta?
Make the answer very short. 20.48. In the year 1981, what is the difference between the Value added (in %) in Gabon and Value added (in %) in Papua New Guinea?
Your answer should be compact. 23.54. In the year 1981, what is the difference between the Value added (in %) in Malta and Value added (in %) in Papua New Guinea?
Provide a succinct answer. 3.05. What is the ratio of the Value added (in %) of Austria in 1973 to that in 1974?
Provide a succinct answer. 0.94. What is the ratio of the Value added (in %) of Gabon in 1973 to that in 1974?
Keep it short and to the point. 0.94. What is the ratio of the Value added (in %) in Malta in 1973 to that in 1974?
Give a very brief answer. 0.99. What is the ratio of the Value added (in %) in Papua New Guinea in 1973 to that in 1974?
Offer a terse response. 1.01. What is the ratio of the Value added (in %) of Austria in 1973 to that in 1975?
Offer a very short reply. 0.96. What is the ratio of the Value added (in %) of Gabon in 1973 to that in 1975?
Your response must be concise. 0.9. What is the ratio of the Value added (in %) in Malta in 1973 to that in 1975?
Your answer should be very brief. 1.14. What is the ratio of the Value added (in %) of Papua New Guinea in 1973 to that in 1975?
Provide a short and direct response. 0.98. What is the ratio of the Value added (in %) of Gabon in 1973 to that in 1976?
Offer a very short reply. 0.91. What is the ratio of the Value added (in %) in Malta in 1973 to that in 1976?
Ensure brevity in your answer.  1.13. What is the ratio of the Value added (in %) of Papua New Guinea in 1973 to that in 1976?
Give a very brief answer. 1.05. What is the ratio of the Value added (in %) in Austria in 1973 to that in 1977?
Make the answer very short. 1. What is the ratio of the Value added (in %) of Gabon in 1973 to that in 1977?
Your response must be concise. 0.86. What is the ratio of the Value added (in %) of Malta in 1973 to that in 1977?
Your answer should be compact. 1.09. What is the ratio of the Value added (in %) in Papua New Guinea in 1973 to that in 1977?
Offer a very short reply. 1.19. What is the ratio of the Value added (in %) of Austria in 1973 to that in 1978?
Keep it short and to the point. 0.98. What is the ratio of the Value added (in %) of Gabon in 1973 to that in 1978?
Your answer should be very brief. 0.88. What is the ratio of the Value added (in %) of Malta in 1973 to that in 1978?
Offer a very short reply. 1.1. What is the ratio of the Value added (in %) in Papua New Guinea in 1973 to that in 1978?
Your response must be concise. 0.95. What is the ratio of the Value added (in %) of Austria in 1973 to that in 1980?
Keep it short and to the point. 1.02. What is the ratio of the Value added (in %) in Gabon in 1973 to that in 1980?
Provide a succinct answer. 0.89. What is the ratio of the Value added (in %) in Malta in 1973 to that in 1980?
Your answer should be very brief. 1.07. What is the ratio of the Value added (in %) of Papua New Guinea in 1973 to that in 1980?
Offer a terse response. 0.82. What is the ratio of the Value added (in %) of Austria in 1973 to that in 1981?
Your response must be concise. 1.03. What is the ratio of the Value added (in %) in Gabon in 1973 to that in 1981?
Your answer should be compact. 0.92. What is the ratio of the Value added (in %) in Malta in 1973 to that in 1981?
Your response must be concise. 1.09. What is the ratio of the Value added (in %) of Papua New Guinea in 1973 to that in 1981?
Your response must be concise. 0.94. What is the ratio of the Value added (in %) in Austria in 1974 to that in 1975?
Provide a short and direct response. 1.02. What is the ratio of the Value added (in %) in Gabon in 1974 to that in 1975?
Your answer should be compact. 0.95. What is the ratio of the Value added (in %) in Malta in 1974 to that in 1975?
Give a very brief answer. 1.16. What is the ratio of the Value added (in %) in Papua New Guinea in 1974 to that in 1975?
Make the answer very short. 0.97. What is the ratio of the Value added (in %) of Austria in 1974 to that in 1976?
Offer a very short reply. 1.06. What is the ratio of the Value added (in %) of Gabon in 1974 to that in 1976?
Offer a very short reply. 0.96. What is the ratio of the Value added (in %) in Malta in 1974 to that in 1976?
Ensure brevity in your answer.  1.14. What is the ratio of the Value added (in %) in Papua New Guinea in 1974 to that in 1976?
Provide a short and direct response. 1.04. What is the ratio of the Value added (in %) in Austria in 1974 to that in 1977?
Give a very brief answer. 1.06. What is the ratio of the Value added (in %) in Malta in 1974 to that in 1977?
Give a very brief answer. 1.1. What is the ratio of the Value added (in %) of Papua New Guinea in 1974 to that in 1977?
Offer a terse response. 1.17. What is the ratio of the Value added (in %) of Austria in 1974 to that in 1978?
Ensure brevity in your answer.  1.04. What is the ratio of the Value added (in %) of Malta in 1974 to that in 1978?
Make the answer very short. 1.11. What is the ratio of the Value added (in %) in Papua New Guinea in 1974 to that in 1978?
Keep it short and to the point. 0.94. What is the ratio of the Value added (in %) of Austria in 1974 to that in 1980?
Offer a terse response. 1.08. What is the ratio of the Value added (in %) in Gabon in 1974 to that in 1980?
Your response must be concise. 0.95. What is the ratio of the Value added (in %) of Malta in 1974 to that in 1980?
Ensure brevity in your answer.  1.08. What is the ratio of the Value added (in %) in Papua New Guinea in 1974 to that in 1980?
Your answer should be very brief. 0.81. What is the ratio of the Value added (in %) of Austria in 1974 to that in 1981?
Your response must be concise. 1.09. What is the ratio of the Value added (in %) in Gabon in 1974 to that in 1981?
Your response must be concise. 0.98. What is the ratio of the Value added (in %) in Malta in 1974 to that in 1981?
Make the answer very short. 1.11. What is the ratio of the Value added (in %) of Papua New Guinea in 1974 to that in 1981?
Offer a terse response. 0.93. What is the ratio of the Value added (in %) in Austria in 1975 to that in 1976?
Make the answer very short. 1.04. What is the ratio of the Value added (in %) in Gabon in 1975 to that in 1976?
Provide a short and direct response. 1.01. What is the ratio of the Value added (in %) in Malta in 1975 to that in 1976?
Provide a short and direct response. 0.99. What is the ratio of the Value added (in %) in Papua New Guinea in 1975 to that in 1976?
Make the answer very short. 1.07. What is the ratio of the Value added (in %) in Austria in 1975 to that in 1977?
Your answer should be very brief. 1.04. What is the ratio of the Value added (in %) in Gabon in 1975 to that in 1977?
Offer a very short reply. 0.96. What is the ratio of the Value added (in %) of Malta in 1975 to that in 1977?
Offer a terse response. 0.95. What is the ratio of the Value added (in %) in Papua New Guinea in 1975 to that in 1977?
Ensure brevity in your answer.  1.21. What is the ratio of the Value added (in %) of Austria in 1975 to that in 1978?
Provide a succinct answer. 1.02. What is the ratio of the Value added (in %) in Gabon in 1975 to that in 1978?
Your answer should be compact. 0.99. What is the ratio of the Value added (in %) of Malta in 1975 to that in 1978?
Your answer should be very brief. 0.96. What is the ratio of the Value added (in %) in Papua New Guinea in 1975 to that in 1978?
Ensure brevity in your answer.  0.97. What is the ratio of the Value added (in %) of Austria in 1975 to that in 1980?
Your answer should be compact. 1.06. What is the ratio of the Value added (in %) of Gabon in 1975 to that in 1980?
Ensure brevity in your answer.  0.99. What is the ratio of the Value added (in %) in Malta in 1975 to that in 1980?
Provide a succinct answer. 0.94. What is the ratio of the Value added (in %) of Papua New Guinea in 1975 to that in 1980?
Give a very brief answer. 0.84. What is the ratio of the Value added (in %) in Austria in 1975 to that in 1981?
Ensure brevity in your answer.  1.07. What is the ratio of the Value added (in %) of Gabon in 1975 to that in 1981?
Provide a short and direct response. 1.03. What is the ratio of the Value added (in %) in Malta in 1975 to that in 1981?
Your response must be concise. 0.96. What is the ratio of the Value added (in %) of Papua New Guinea in 1975 to that in 1981?
Your answer should be compact. 0.96. What is the ratio of the Value added (in %) of Austria in 1976 to that in 1977?
Your response must be concise. 1. What is the ratio of the Value added (in %) of Gabon in 1976 to that in 1977?
Keep it short and to the point. 0.95. What is the ratio of the Value added (in %) of Malta in 1976 to that in 1977?
Your answer should be very brief. 0.97. What is the ratio of the Value added (in %) of Papua New Guinea in 1976 to that in 1977?
Your answer should be very brief. 1.13. What is the ratio of the Value added (in %) of Austria in 1976 to that in 1978?
Make the answer very short. 0.98. What is the ratio of the Value added (in %) of Gabon in 1976 to that in 1978?
Your answer should be compact. 0.98. What is the ratio of the Value added (in %) of Malta in 1976 to that in 1978?
Keep it short and to the point. 0.97. What is the ratio of the Value added (in %) in Papua New Guinea in 1976 to that in 1978?
Your answer should be very brief. 0.9. What is the ratio of the Value added (in %) in Austria in 1976 to that in 1980?
Give a very brief answer. 1.02. What is the ratio of the Value added (in %) of Gabon in 1976 to that in 1980?
Make the answer very short. 0.98. What is the ratio of the Value added (in %) of Malta in 1976 to that in 1980?
Your response must be concise. 0.95. What is the ratio of the Value added (in %) in Papua New Guinea in 1976 to that in 1980?
Offer a very short reply. 0.78. What is the ratio of the Value added (in %) of Austria in 1976 to that in 1981?
Provide a succinct answer. 1.03. What is the ratio of the Value added (in %) of Gabon in 1976 to that in 1981?
Make the answer very short. 1.02. What is the ratio of the Value added (in %) of Malta in 1976 to that in 1981?
Your answer should be very brief. 0.97. What is the ratio of the Value added (in %) of Papua New Guinea in 1976 to that in 1981?
Keep it short and to the point. 0.9. What is the ratio of the Value added (in %) of Austria in 1977 to that in 1978?
Your answer should be very brief. 0.98. What is the ratio of the Value added (in %) in Gabon in 1977 to that in 1978?
Make the answer very short. 1.03. What is the ratio of the Value added (in %) of Papua New Guinea in 1977 to that in 1978?
Your response must be concise. 0.8. What is the ratio of the Value added (in %) of Austria in 1977 to that in 1980?
Provide a succinct answer. 1.01. What is the ratio of the Value added (in %) of Gabon in 1977 to that in 1980?
Give a very brief answer. 1.03. What is the ratio of the Value added (in %) in Malta in 1977 to that in 1980?
Give a very brief answer. 0.98. What is the ratio of the Value added (in %) in Papua New Guinea in 1977 to that in 1980?
Provide a succinct answer. 0.69. What is the ratio of the Value added (in %) in Austria in 1977 to that in 1981?
Give a very brief answer. 1.02. What is the ratio of the Value added (in %) in Gabon in 1977 to that in 1981?
Ensure brevity in your answer.  1.07. What is the ratio of the Value added (in %) in Papua New Guinea in 1977 to that in 1981?
Offer a very short reply. 0.8. What is the ratio of the Value added (in %) of Austria in 1978 to that in 1980?
Offer a very short reply. 1.04. What is the ratio of the Value added (in %) in Gabon in 1978 to that in 1980?
Your answer should be very brief. 1. What is the ratio of the Value added (in %) in Malta in 1978 to that in 1980?
Provide a short and direct response. 0.97. What is the ratio of the Value added (in %) of Papua New Guinea in 1978 to that in 1980?
Ensure brevity in your answer.  0.87. What is the ratio of the Value added (in %) in Austria in 1978 to that in 1981?
Your answer should be very brief. 1.05. What is the ratio of the Value added (in %) of Gabon in 1978 to that in 1981?
Provide a short and direct response. 1.05. What is the ratio of the Value added (in %) in Papua New Guinea in 1978 to that in 1981?
Your answer should be very brief. 1. What is the ratio of the Value added (in %) of Austria in 1980 to that in 1981?
Offer a terse response. 1.01. What is the ratio of the Value added (in %) of Gabon in 1980 to that in 1981?
Offer a very short reply. 1.04. What is the ratio of the Value added (in %) in Malta in 1980 to that in 1981?
Offer a very short reply. 1.02. What is the ratio of the Value added (in %) in Papua New Guinea in 1980 to that in 1981?
Offer a terse response. 1.15. What is the difference between the highest and the second highest Value added (in %) of Austria?
Give a very brief answer. 1.15. What is the difference between the highest and the second highest Value added (in %) in Gabon?
Provide a succinct answer. 1.65. What is the difference between the highest and the second highest Value added (in %) in Malta?
Provide a succinct answer. 0.45. What is the difference between the highest and the second highest Value added (in %) of Papua New Guinea?
Your answer should be compact. 5.36. What is the difference between the highest and the lowest Value added (in %) in Austria?
Ensure brevity in your answer.  4.55. What is the difference between the highest and the lowest Value added (in %) of Gabon?
Provide a short and direct response. 8.87. What is the difference between the highest and the lowest Value added (in %) in Malta?
Keep it short and to the point. 5.8. What is the difference between the highest and the lowest Value added (in %) of Papua New Guinea?
Provide a succinct answer. 12.64. 